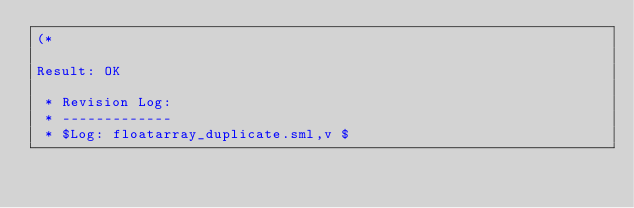<code> <loc_0><loc_0><loc_500><loc_500><_SML_>(*

Result: OK
 
 * Revision Log:
 * -------------
 * $Log: floatarray_duplicate.sml,v $</code> 